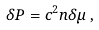<formula> <loc_0><loc_0><loc_500><loc_500>\delta P = c ^ { 2 } n \delta \mu \, ,</formula> 